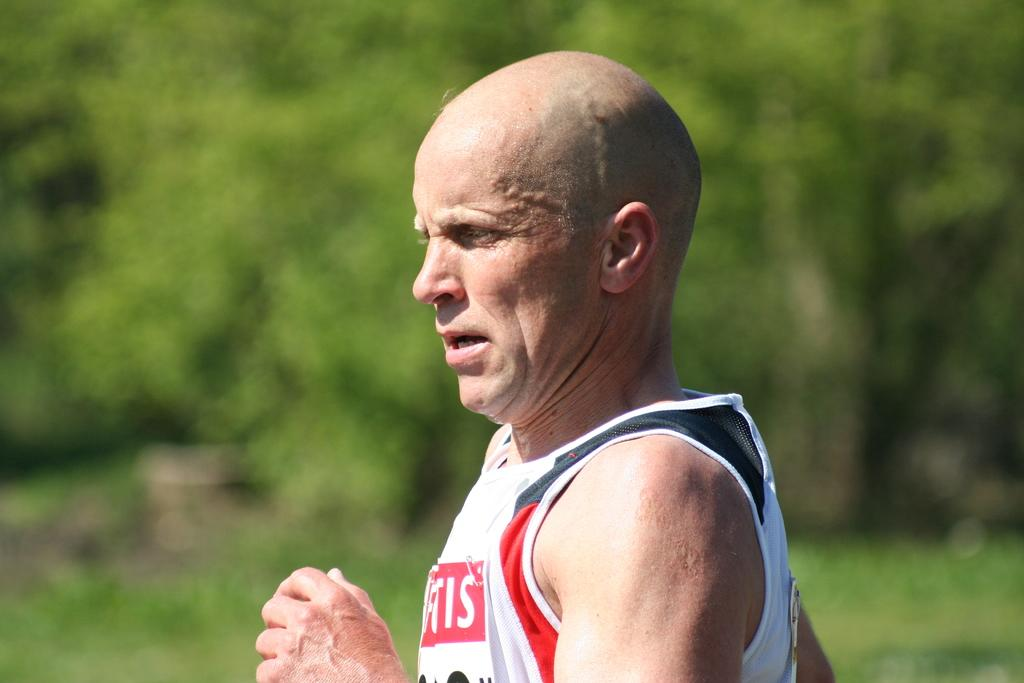Provide a one-sentence caption for the provided image. A older caucasian man running wearing a white shirt with the letters IS. 